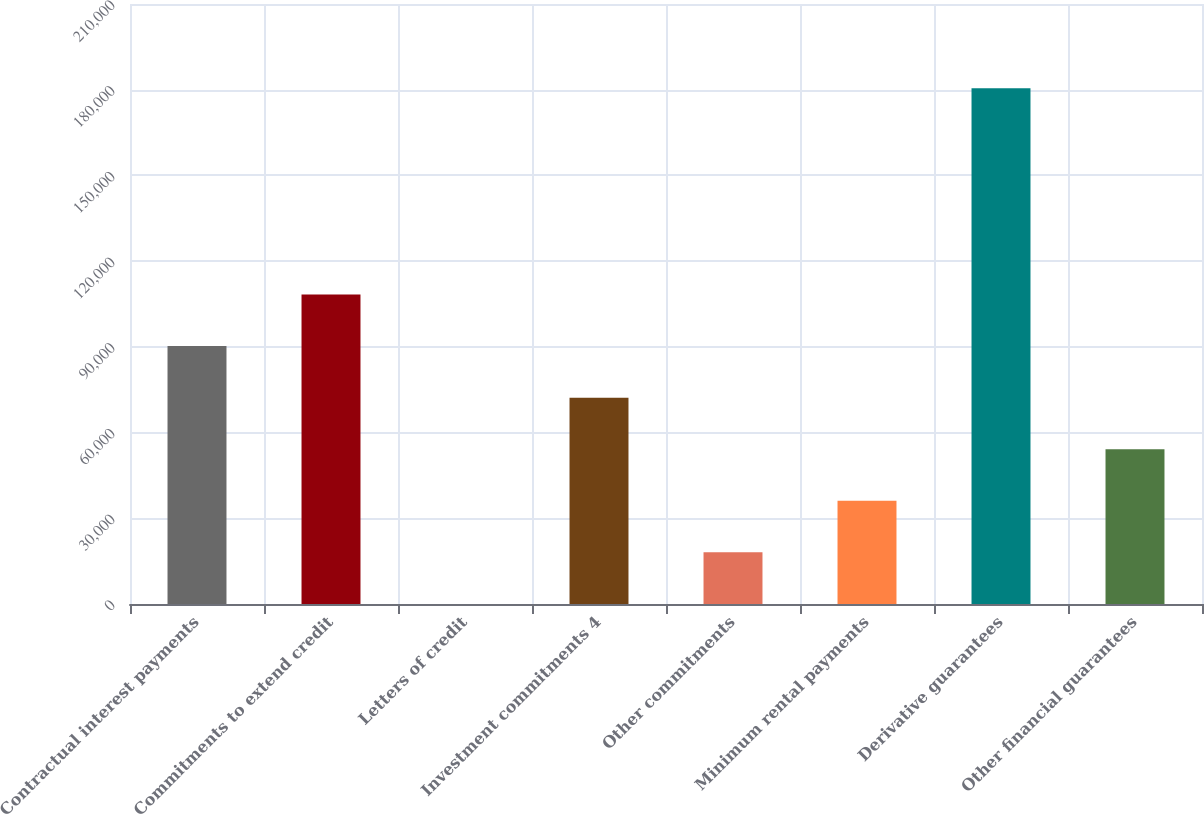Convert chart. <chart><loc_0><loc_0><loc_500><loc_500><bar_chart><fcel>Contractual interest payments<fcel>Commitments to extend credit<fcel>Letters of credit<fcel>Investment commitments 4<fcel>Other commitments<fcel>Minimum rental payments<fcel>Derivative guarantees<fcel>Other financial guarantees<nl><fcel>90282<fcel>108334<fcel>21<fcel>72229.8<fcel>18073.2<fcel>36125.4<fcel>180543<fcel>54177.6<nl></chart> 